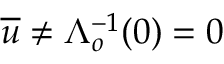Convert formula to latex. <formula><loc_0><loc_0><loc_500><loc_500>\overline { u } \ne \Lambda _ { o } ^ { - 1 } ( 0 ) = 0</formula> 